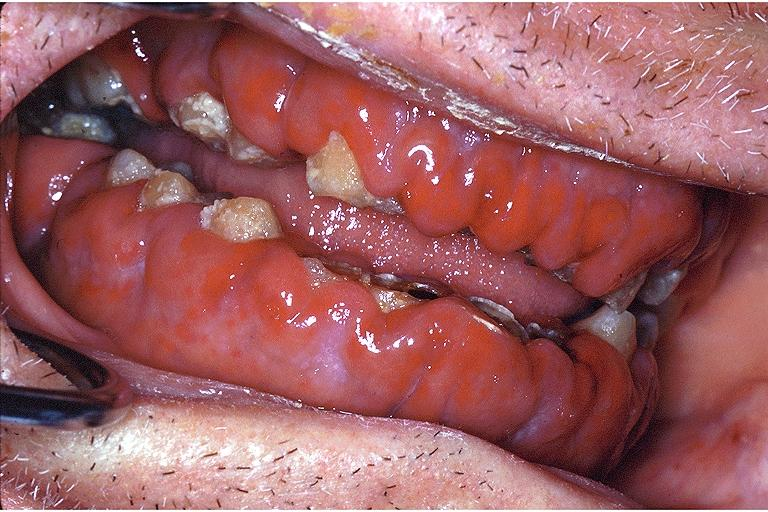does this image show gingival leukemic infiltrate?
Answer the question using a single word or phrase. Yes 